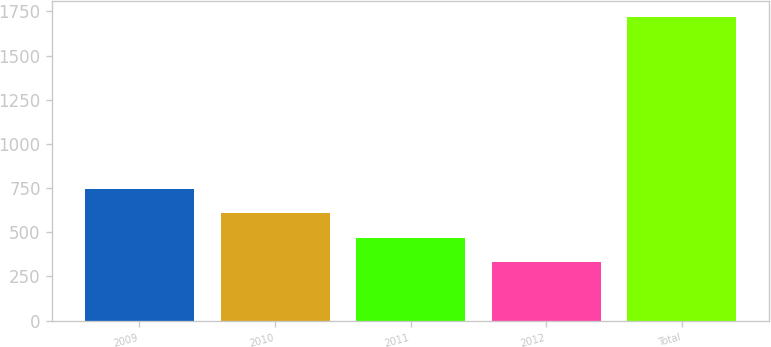Convert chart. <chart><loc_0><loc_0><loc_500><loc_500><bar_chart><fcel>2009<fcel>2010<fcel>2011<fcel>2012<fcel>Total<nl><fcel>747.3<fcel>608.2<fcel>469.1<fcel>330<fcel>1721<nl></chart> 